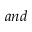<formula> <loc_0><loc_0><loc_500><loc_500>a n d</formula> 